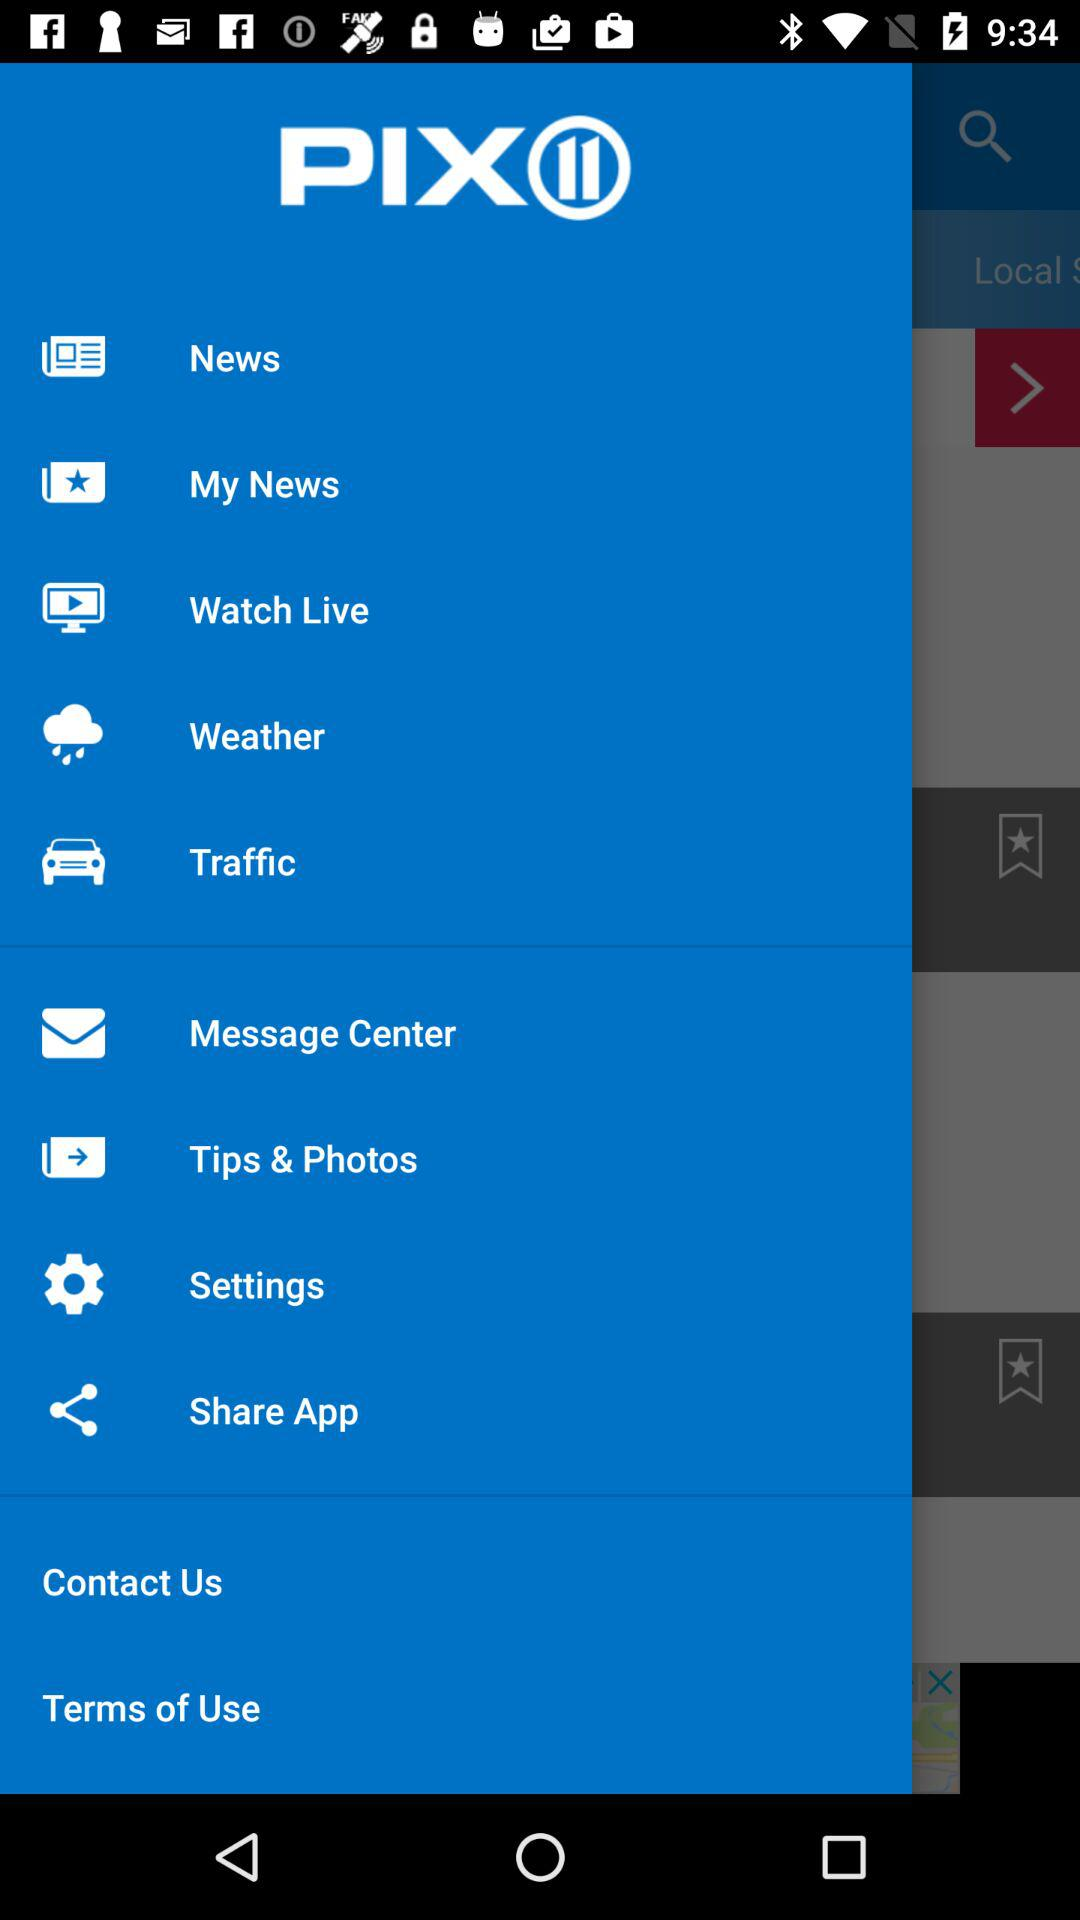What is the name of the application? The name of the application is "PIX 11". 